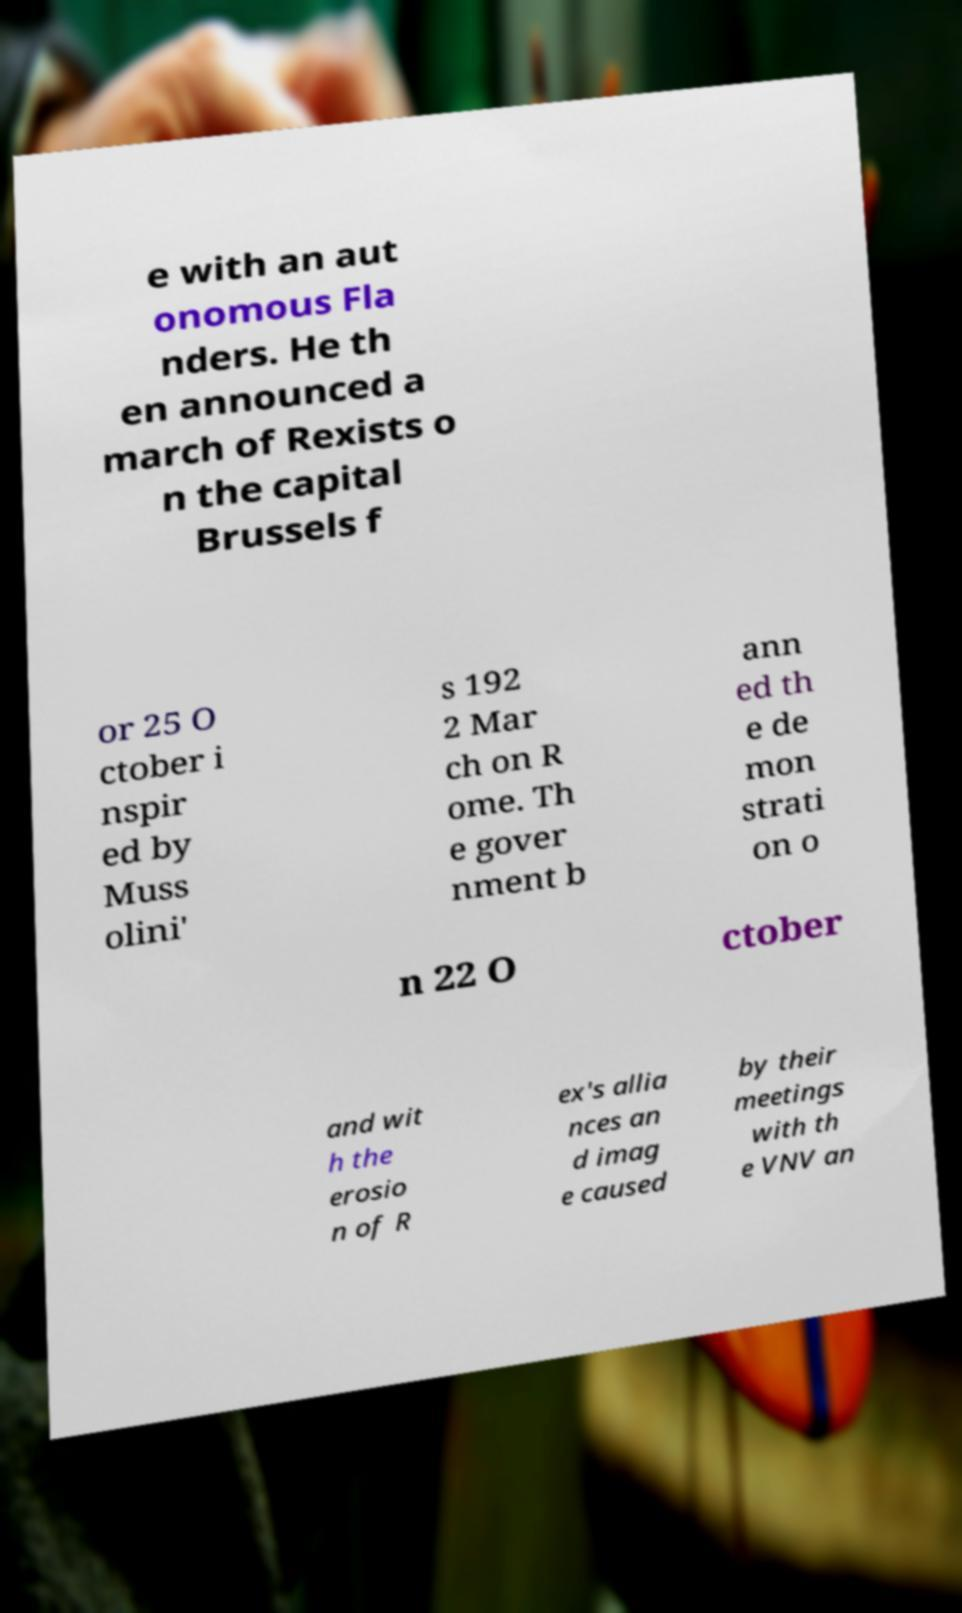Could you extract and type out the text from this image? e with an aut onomous Fla nders. He th en announced a march of Rexists o n the capital Brussels f or 25 O ctober i nspir ed by Muss olini' s 192 2 Mar ch on R ome. Th e gover nment b ann ed th e de mon strati on o n 22 O ctober and wit h the erosio n of R ex's allia nces an d imag e caused by their meetings with th e VNV an 